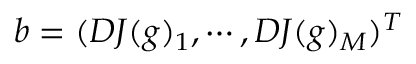Convert formula to latex. <formula><loc_0><loc_0><loc_500><loc_500>b = ( D J ( g ) _ { 1 } , \cdots , D J ( g ) _ { M } ) ^ { T }</formula> 